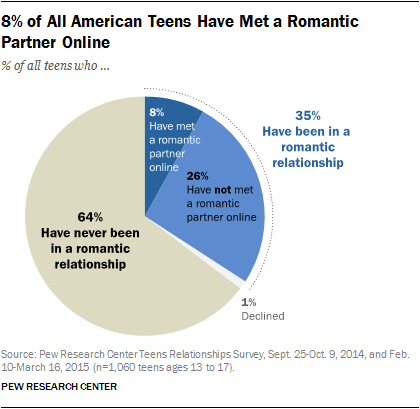Point out several critical features in this image. I calculated the sum of the light and dark blue segments and then multiplied it by 2. If the result is greater than the largest segment, then the answer is yes. The answer is no. 